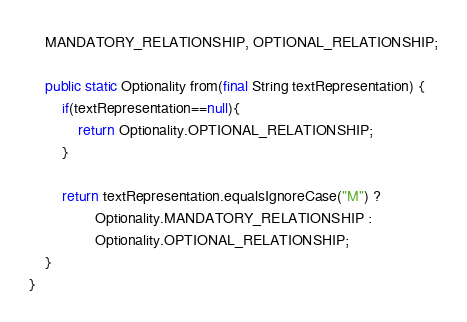<code> <loc_0><loc_0><loc_500><loc_500><_Java_>    MANDATORY_RELATIONSHIP, OPTIONAL_RELATIONSHIP;

    public static Optionality from(final String textRepresentation) {
        if(textRepresentation==null){
            return Optionality.OPTIONAL_RELATIONSHIP;
        }

        return textRepresentation.equalsIgnoreCase("M") ?
                Optionality.MANDATORY_RELATIONSHIP :
                Optionality.OPTIONAL_RELATIONSHIP;
    }
}
</code> 